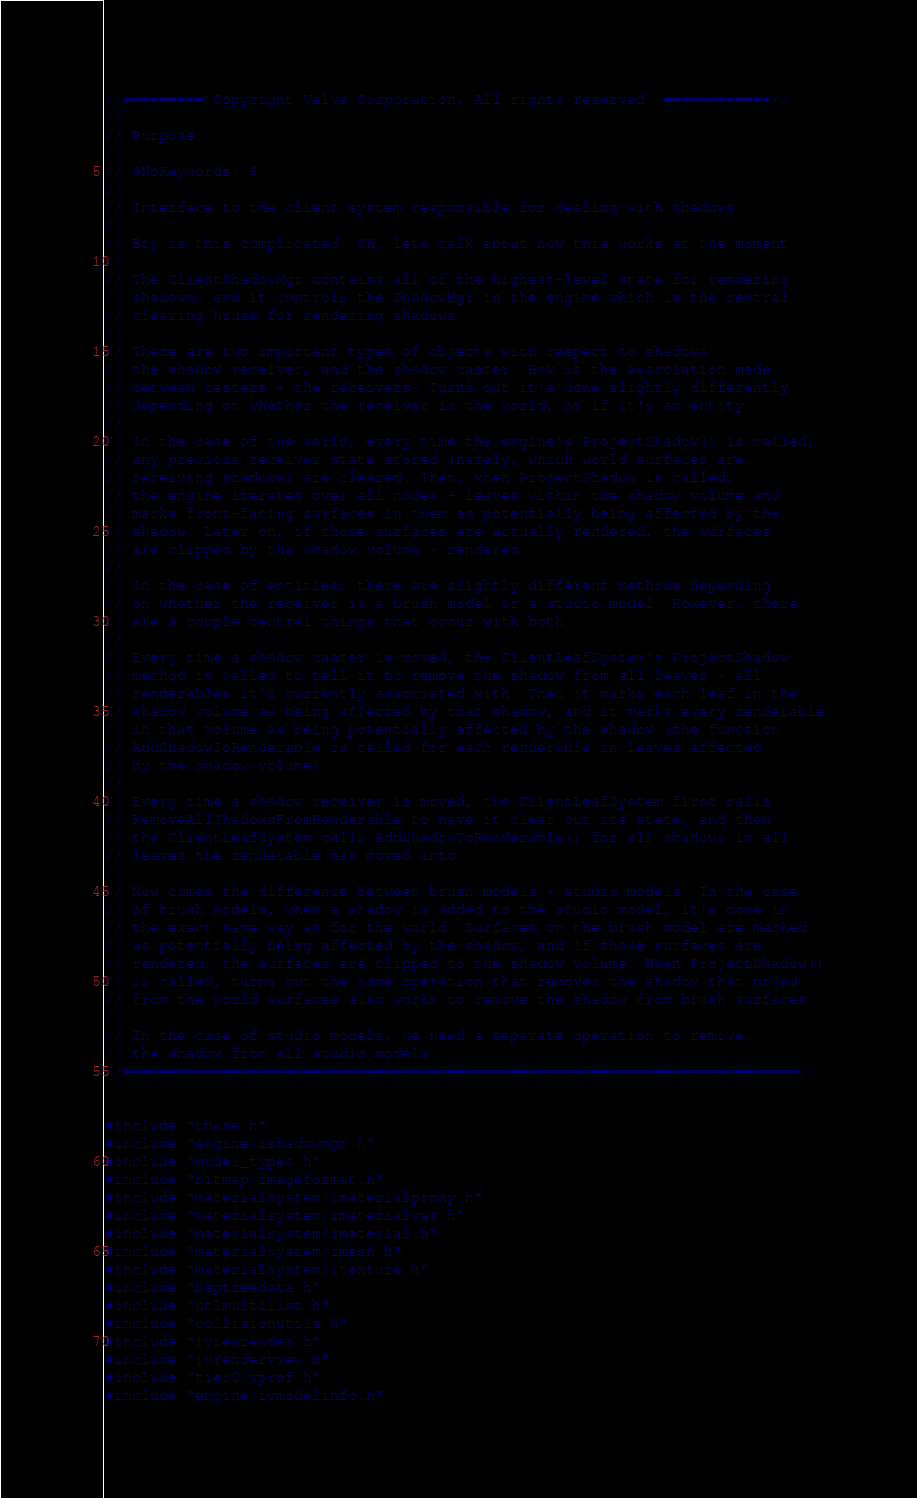Convert code to text. <code><loc_0><loc_0><loc_500><loc_500><_C++_>//========= Copyright Valve Corporation, All rights reserved. ============//
//
// Purpose: 
//
// $NoKeywords: $
//
// Interface to the client system responsible for dealing with shadows
//
// Boy is this complicated. OK, lets talk about how this works at the moment
//
// The ClientShadowMgr contains all of the highest-level state for rendering
// shadows, and it controls the ShadowMgr in the engine which is the central
// clearing house for rendering shadows.
//
// There are two important types of objects with respect to shadows:
// the shadow receiver, and the shadow caster. How is the association made
// between casters + the receivers? Turns out it's done slightly differently 
// depending on whether the receiver is the world, or if it's an entity.
//
// In the case of the world, every time the engine's ProjectShadow() is called, 
// any previous receiver state stored (namely, which world surfaces are
// receiving shadows) are cleared. Then, when ProjectShadow is called, 
// the engine iterates over all nodes + leaves within the shadow volume and 
// marks front-facing surfaces in them as potentially being affected by the 
// shadow. Later on, if those surfaces are actually rendered, the surfaces
// are clipped by the shadow volume + rendered.
// 
// In the case of entities, there are slightly different methods depending
// on whether the receiver is a brush model or a studio model. However, there
// are a couple central things that occur with both.
//
// Every time a shadow caster is moved, the ClientLeafSystem's ProjectShadow
// method is called to tell it to remove the shadow from all leaves + all 
// renderables it's currently associated with. Then it marks each leaf in the
// shadow volume as being affected by that shadow, and it marks every renderable
// in that volume as being potentially affected by the shadow (the function
// AddShadowToRenderable is called for each renderable in leaves affected
// by the shadow volume).
//
// Every time a shadow receiver is moved, the ClientLeafSystem first calls 
// RemoveAllShadowsFromRenderable to have it clear out its state, and then
// the ClientLeafSystem calls AddShadowToRenderable() for all shadows in all
// leaves the renderable has moved into.
//
// Now comes the difference between brush models + studio models. In the case
// of brush models, when a shadow is added to the studio model, it's done in
// the exact same way as for the world. Surfaces on the brush model are marked
// as potentially being affected by the shadow, and if those surfaces are
// rendered, the surfaces are clipped to the shadow volume. When ProjectShadow()
// is called, turns out the same operation that removes the shadow that moved
// from the world surfaces also works to remove the shadow from brush surfaces.
//
// In the case of studio models, we need a separate operation to remove
// the shadow from all studio models
//===========================================================================//


#include "cbase.h"
#include "engine/ishadowmgr.h"
#include "model_types.h"
#include "bitmap/imageformat.h"
#include "materialsystem/imaterialproxy.h"
#include "materialsystem/imaterialvar.h"
#include "materialsystem/imaterial.h"
#include "materialsystem/imesh.h"
#include "materialsystem/itexture.h"
#include "bsptreedata.h"
#include "utlmultilist.h"
#include "collisionutils.h"
#include "iviewrender.h"
#include "ivrenderview.h"
#include "tier0/vprof.h"
#include "engine/ivmodelinfo.h"</code> 